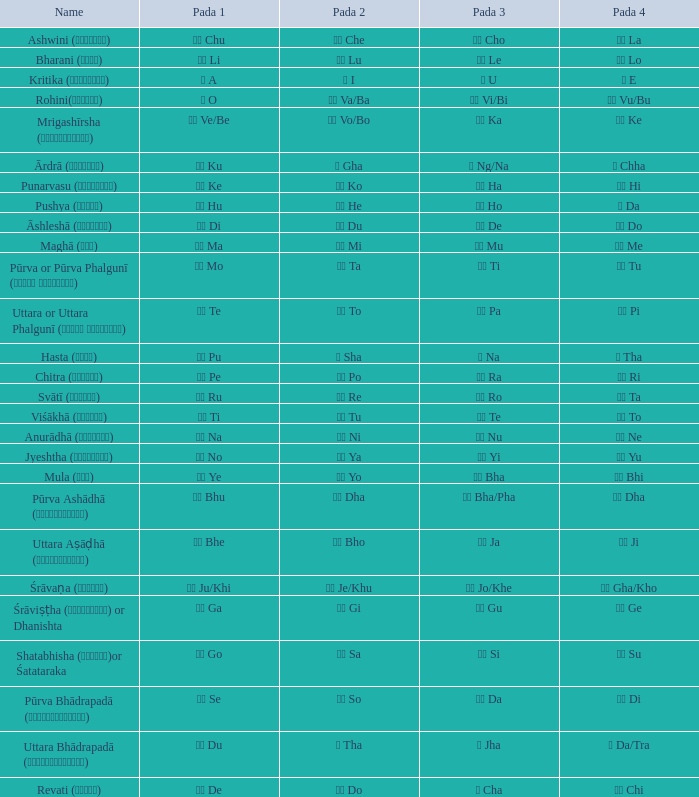In which pada 3 can a pada 1 of टे te be found? पा Pa. 